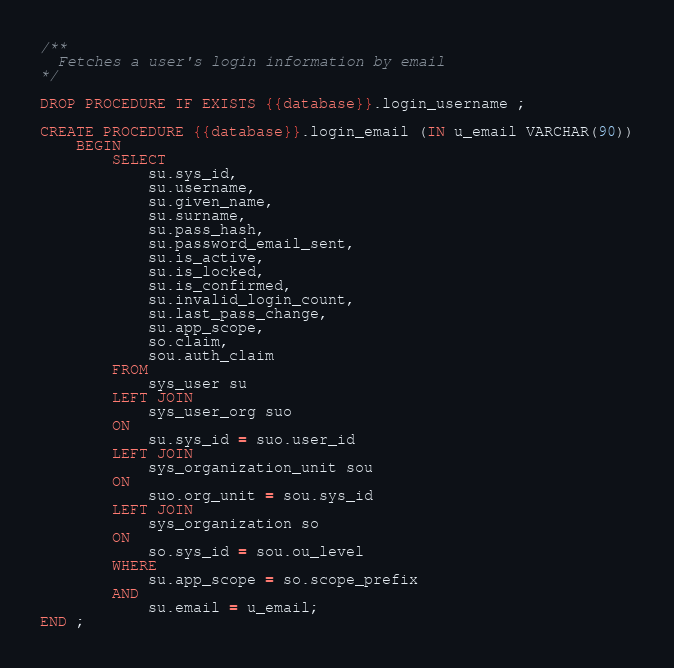<code> <loc_0><loc_0><loc_500><loc_500><_SQL_>/**
  Fetches a user's login information by email
*/

DROP PROCEDURE IF EXISTS {{database}}.login_username ;

CREATE PROCEDURE {{database}}.login_email (IN u_email VARCHAR(90))
    BEGIN
        SELECT
            su.sys_id,
            su.username,
            su.given_name,
            su.surname,
            su.pass_hash,
            su.password_email_sent,
            su.is_active,
            su.is_locked,
            su.is_confirmed,
            su.invalid_login_count,
            su.last_pass_change,
            su.app_scope,
            so.claim,
            sou.auth_claim
        FROM
            sys_user su
        LEFT JOIN
            sys_user_org suo
        ON
            su.sys_id = suo.user_id
        LEFT JOIN
            sys_organization_unit sou
        ON
            suo.org_unit = sou.sys_id
        LEFT JOIN
            sys_organization so
        ON
            so.sys_id = sou.ou_level
        WHERE
            su.app_scope = so.scope_prefix
        AND
            su.email = u_email;
END ;</code> 